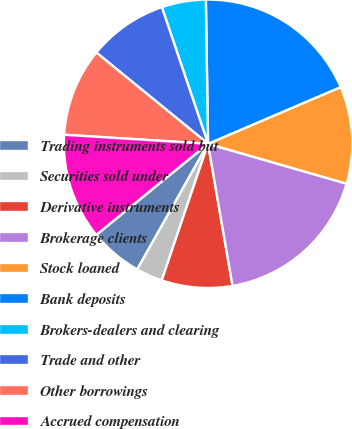Convert chart to OTSL. <chart><loc_0><loc_0><loc_500><loc_500><pie_chart><fcel>Trading instruments sold but<fcel>Securities sold under<fcel>Derivative instruments<fcel>Brokerage clients<fcel>Stock loaned<fcel>Bank deposits<fcel>Brokers-dealers and clearing<fcel>Trade and other<fcel>Other borrowings<fcel>Accrued compensation<nl><fcel>5.94%<fcel>2.97%<fcel>7.92%<fcel>17.82%<fcel>10.89%<fcel>18.81%<fcel>4.95%<fcel>8.91%<fcel>9.9%<fcel>11.88%<nl></chart> 